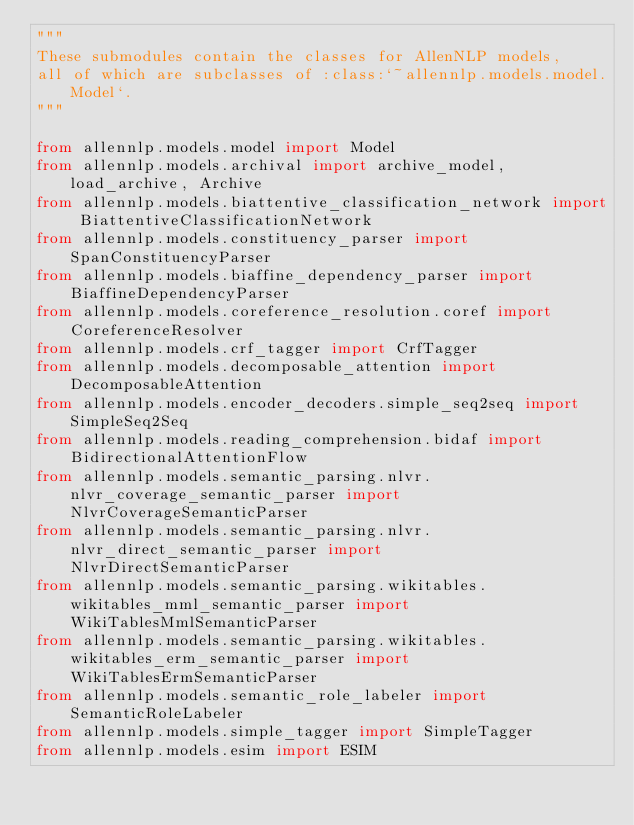<code> <loc_0><loc_0><loc_500><loc_500><_Python_>"""
These submodules contain the classes for AllenNLP models,
all of which are subclasses of :class:`~allennlp.models.model.Model`.
"""

from allennlp.models.model import Model
from allennlp.models.archival import archive_model, load_archive, Archive
from allennlp.models.biattentive_classification_network import BiattentiveClassificationNetwork
from allennlp.models.constituency_parser import SpanConstituencyParser
from allennlp.models.biaffine_dependency_parser import BiaffineDependencyParser
from allennlp.models.coreference_resolution.coref import CoreferenceResolver
from allennlp.models.crf_tagger import CrfTagger
from allennlp.models.decomposable_attention import DecomposableAttention
from allennlp.models.encoder_decoders.simple_seq2seq import SimpleSeq2Seq
from allennlp.models.reading_comprehension.bidaf import BidirectionalAttentionFlow
from allennlp.models.semantic_parsing.nlvr.nlvr_coverage_semantic_parser import NlvrCoverageSemanticParser
from allennlp.models.semantic_parsing.nlvr.nlvr_direct_semantic_parser import NlvrDirectSemanticParser
from allennlp.models.semantic_parsing.wikitables.wikitables_mml_semantic_parser import WikiTablesMmlSemanticParser
from allennlp.models.semantic_parsing.wikitables.wikitables_erm_semantic_parser import WikiTablesErmSemanticParser
from allennlp.models.semantic_role_labeler import SemanticRoleLabeler
from allennlp.models.simple_tagger import SimpleTagger
from allennlp.models.esim import ESIM
</code> 